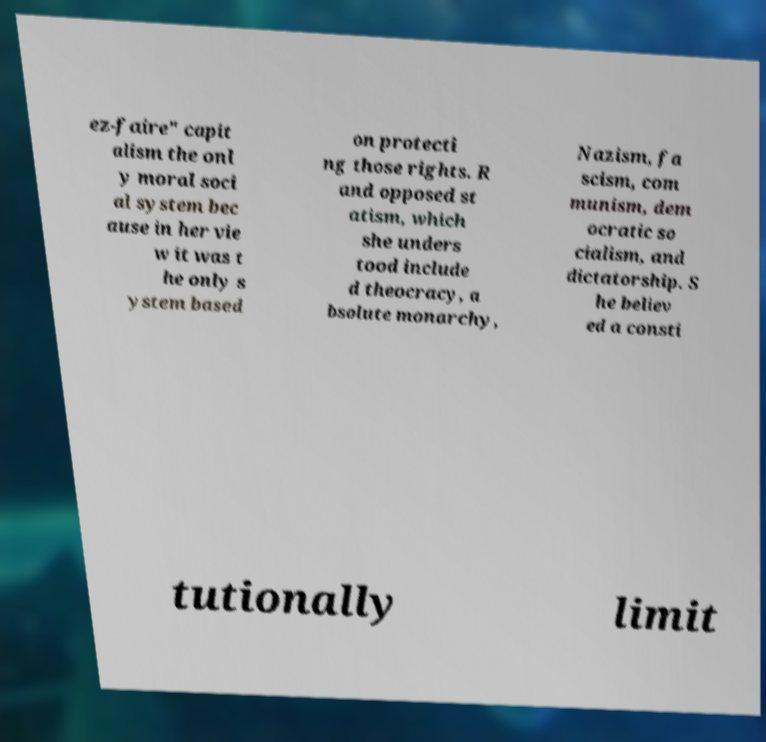I need the written content from this picture converted into text. Can you do that? ez-faire" capit alism the onl y moral soci al system bec ause in her vie w it was t he only s ystem based on protecti ng those rights. R and opposed st atism, which she unders tood include d theocracy, a bsolute monarchy, Nazism, fa scism, com munism, dem ocratic so cialism, and dictatorship. S he believ ed a consti tutionally limit 